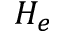<formula> <loc_0><loc_0><loc_500><loc_500>H _ { e }</formula> 